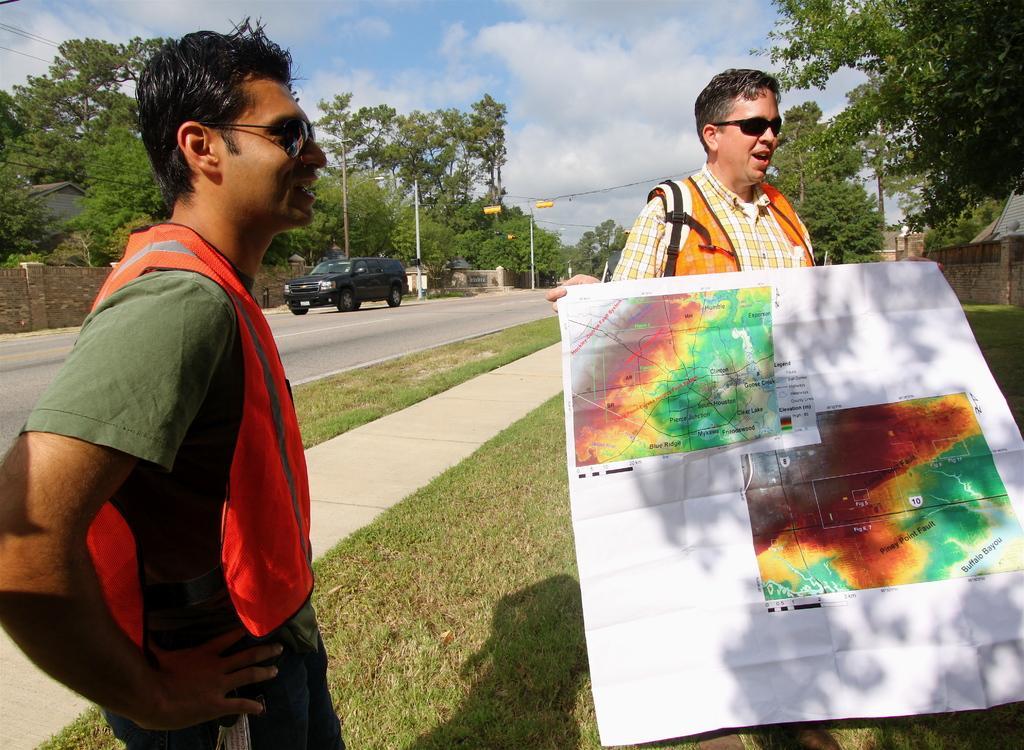Describe this image in one or two sentences. In this picture we can see a person standing on the left side. There is another person holding a white sheet in his hands. On this sheet, we can see a few places. There are few trees, poles, wires and a vehicle on the path. Some grass is visible on the path. A house is visible on the right side. 